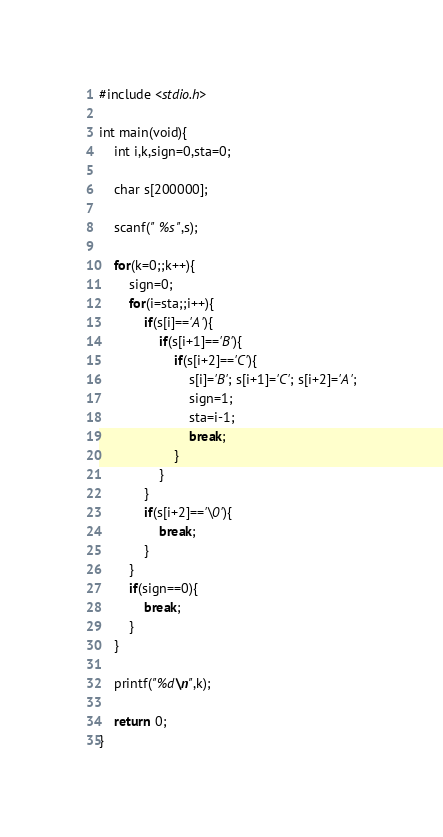Convert code to text. <code><loc_0><loc_0><loc_500><loc_500><_C_>#include <stdio.h>

int main(void){
	int i,k,sign=0,sta=0;
	
	char s[200000];
	
	scanf(" %s",s);
	
	for(k=0;;k++){
		sign=0;
		for(i=sta;;i++){
			if(s[i]=='A'){
				if(s[i+1]=='B'){
					if(s[i+2]=='C'){
						s[i]='B'; s[i+1]='C'; s[i+2]='A';
						sign=1;
						sta=i-1;
						break;
					}
				}
			}
			if(s[i+2]=='\0'){
				break;
			}
		}
		if(sign==0){
			break;
		}
	}
	
	printf("%d\n",k);
	
	return 0;
}</code> 